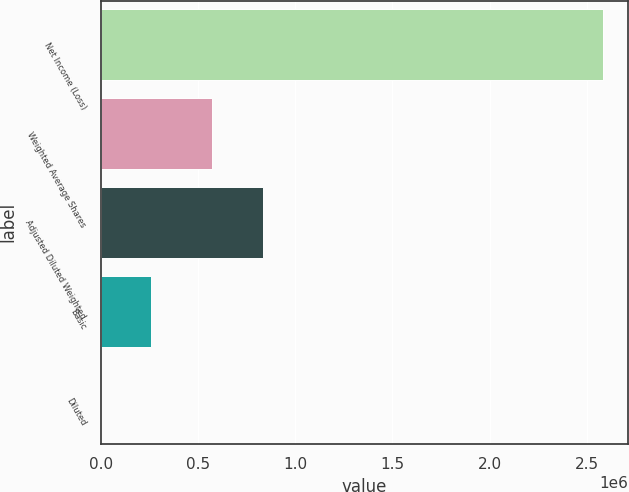Convert chart. <chart><loc_0><loc_0><loc_500><loc_500><bar_chart><fcel>Net Income (Loss)<fcel>Weighted Average Shares<fcel>Adjusted Diluted Weighted<fcel>Basic<fcel>Diluted<nl><fcel>2.58258e+06<fcel>574620<fcel>832877<fcel>258262<fcel>4.46<nl></chart> 